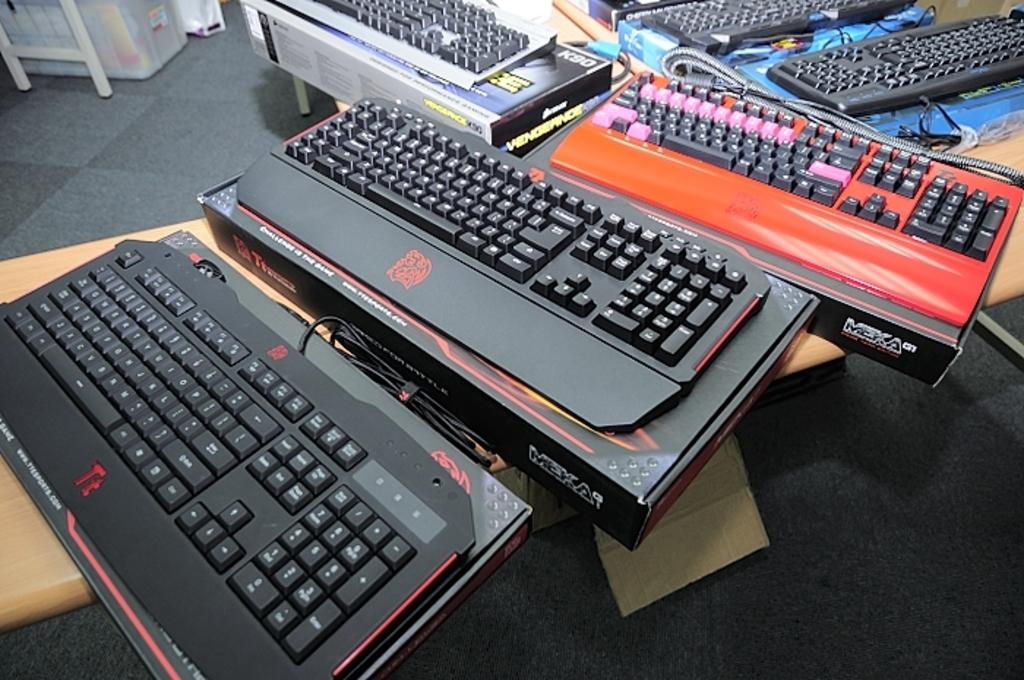<image>
Write a terse but informative summary of the picture. Several Meka computer keyboards are out on a desktop. 